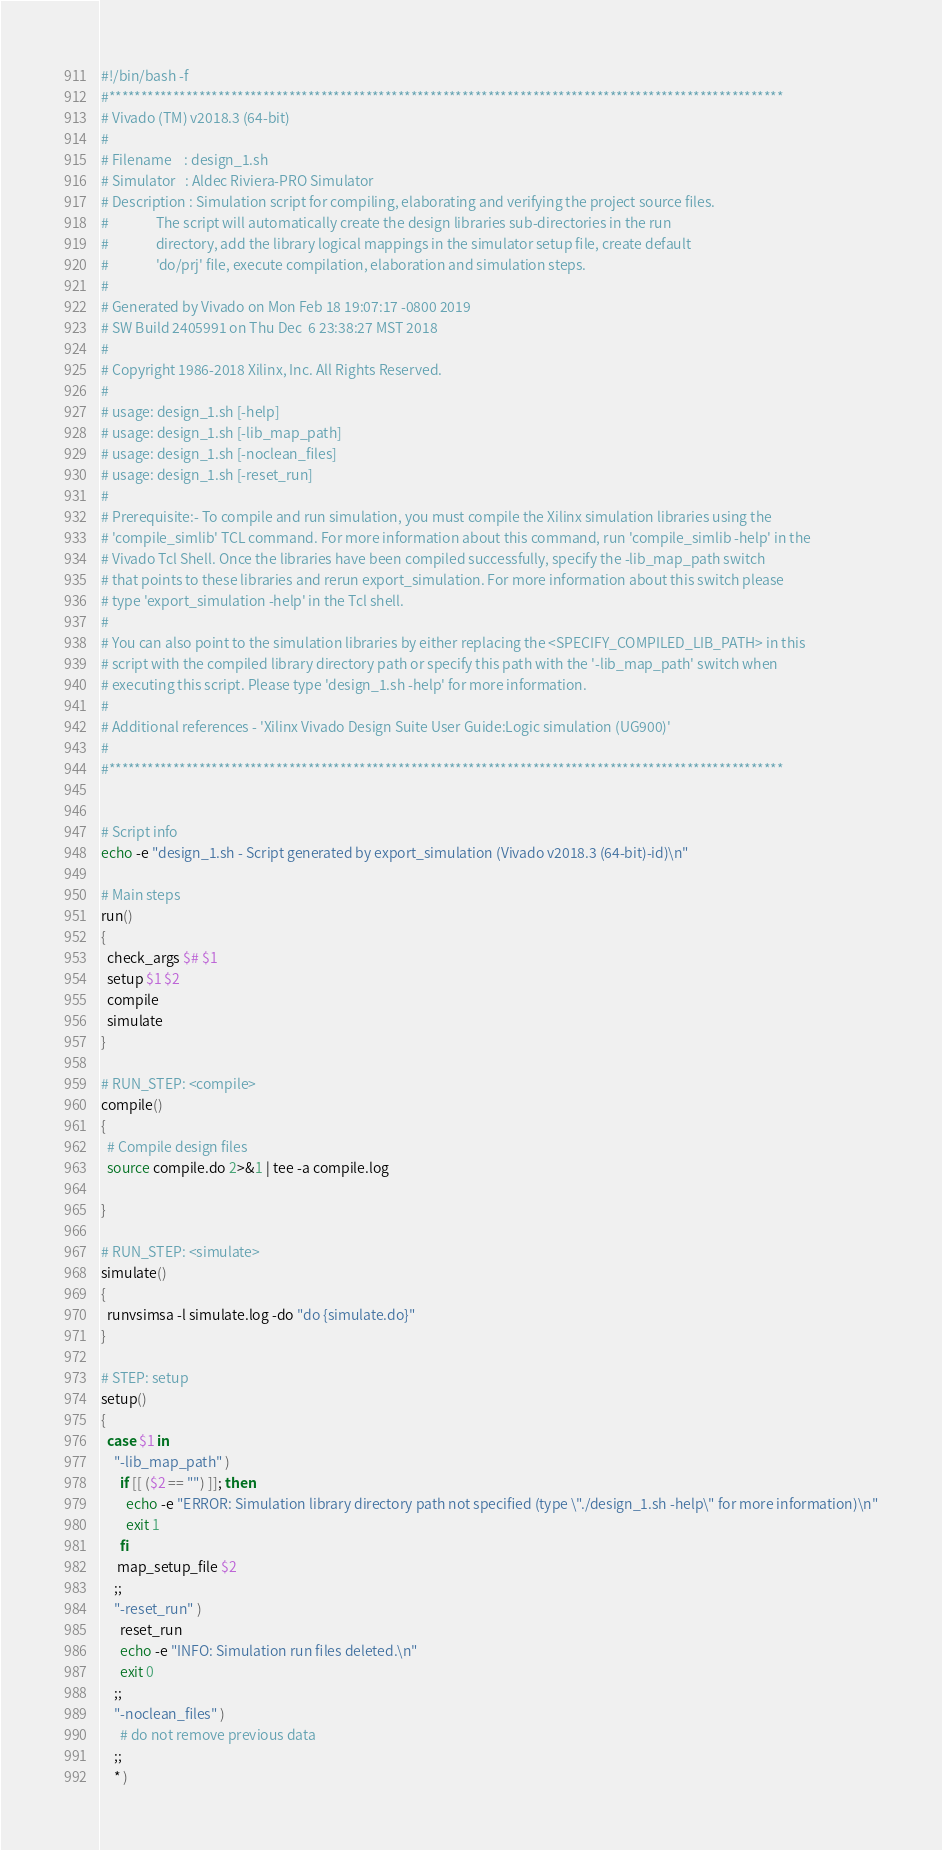Convert code to text. <code><loc_0><loc_0><loc_500><loc_500><_Bash_>#!/bin/bash -f
#*********************************************************************************************************
# Vivado (TM) v2018.3 (64-bit)
#
# Filename    : design_1.sh
# Simulator   : Aldec Riviera-PRO Simulator
# Description : Simulation script for compiling, elaborating and verifying the project source files.
#               The script will automatically create the design libraries sub-directories in the run
#               directory, add the library logical mappings in the simulator setup file, create default
#               'do/prj' file, execute compilation, elaboration and simulation steps.
#
# Generated by Vivado on Mon Feb 18 19:07:17 -0800 2019
# SW Build 2405991 on Thu Dec  6 23:38:27 MST 2018
#
# Copyright 1986-2018 Xilinx, Inc. All Rights Reserved. 
#
# usage: design_1.sh [-help]
# usage: design_1.sh [-lib_map_path]
# usage: design_1.sh [-noclean_files]
# usage: design_1.sh [-reset_run]
#
# Prerequisite:- To compile and run simulation, you must compile the Xilinx simulation libraries using the
# 'compile_simlib' TCL command. For more information about this command, run 'compile_simlib -help' in the
# Vivado Tcl Shell. Once the libraries have been compiled successfully, specify the -lib_map_path switch
# that points to these libraries and rerun export_simulation. For more information about this switch please
# type 'export_simulation -help' in the Tcl shell.
#
# You can also point to the simulation libraries by either replacing the <SPECIFY_COMPILED_LIB_PATH> in this
# script with the compiled library directory path or specify this path with the '-lib_map_path' switch when
# executing this script. Please type 'design_1.sh -help' for more information.
#
# Additional references - 'Xilinx Vivado Design Suite User Guide:Logic simulation (UG900)'
#
#*********************************************************************************************************


# Script info
echo -e "design_1.sh - Script generated by export_simulation (Vivado v2018.3 (64-bit)-id)\n"

# Main steps
run()
{
  check_args $# $1
  setup $1 $2
  compile
  simulate
}

# RUN_STEP: <compile>
compile()
{
  # Compile design files
  source compile.do 2>&1 | tee -a compile.log

}

# RUN_STEP: <simulate>
simulate()
{
  runvsimsa -l simulate.log -do "do {simulate.do}"
}

# STEP: setup
setup()
{
  case $1 in
    "-lib_map_path" )
      if [[ ($2 == "") ]]; then
        echo -e "ERROR: Simulation library directory path not specified (type \"./design_1.sh -help\" for more information)\n"
        exit 1
      fi
     map_setup_file $2
    ;;
    "-reset_run" )
      reset_run
      echo -e "INFO: Simulation run files deleted.\n"
      exit 0
    ;;
    "-noclean_files" )
      # do not remove previous data
    ;;
    * )</code> 